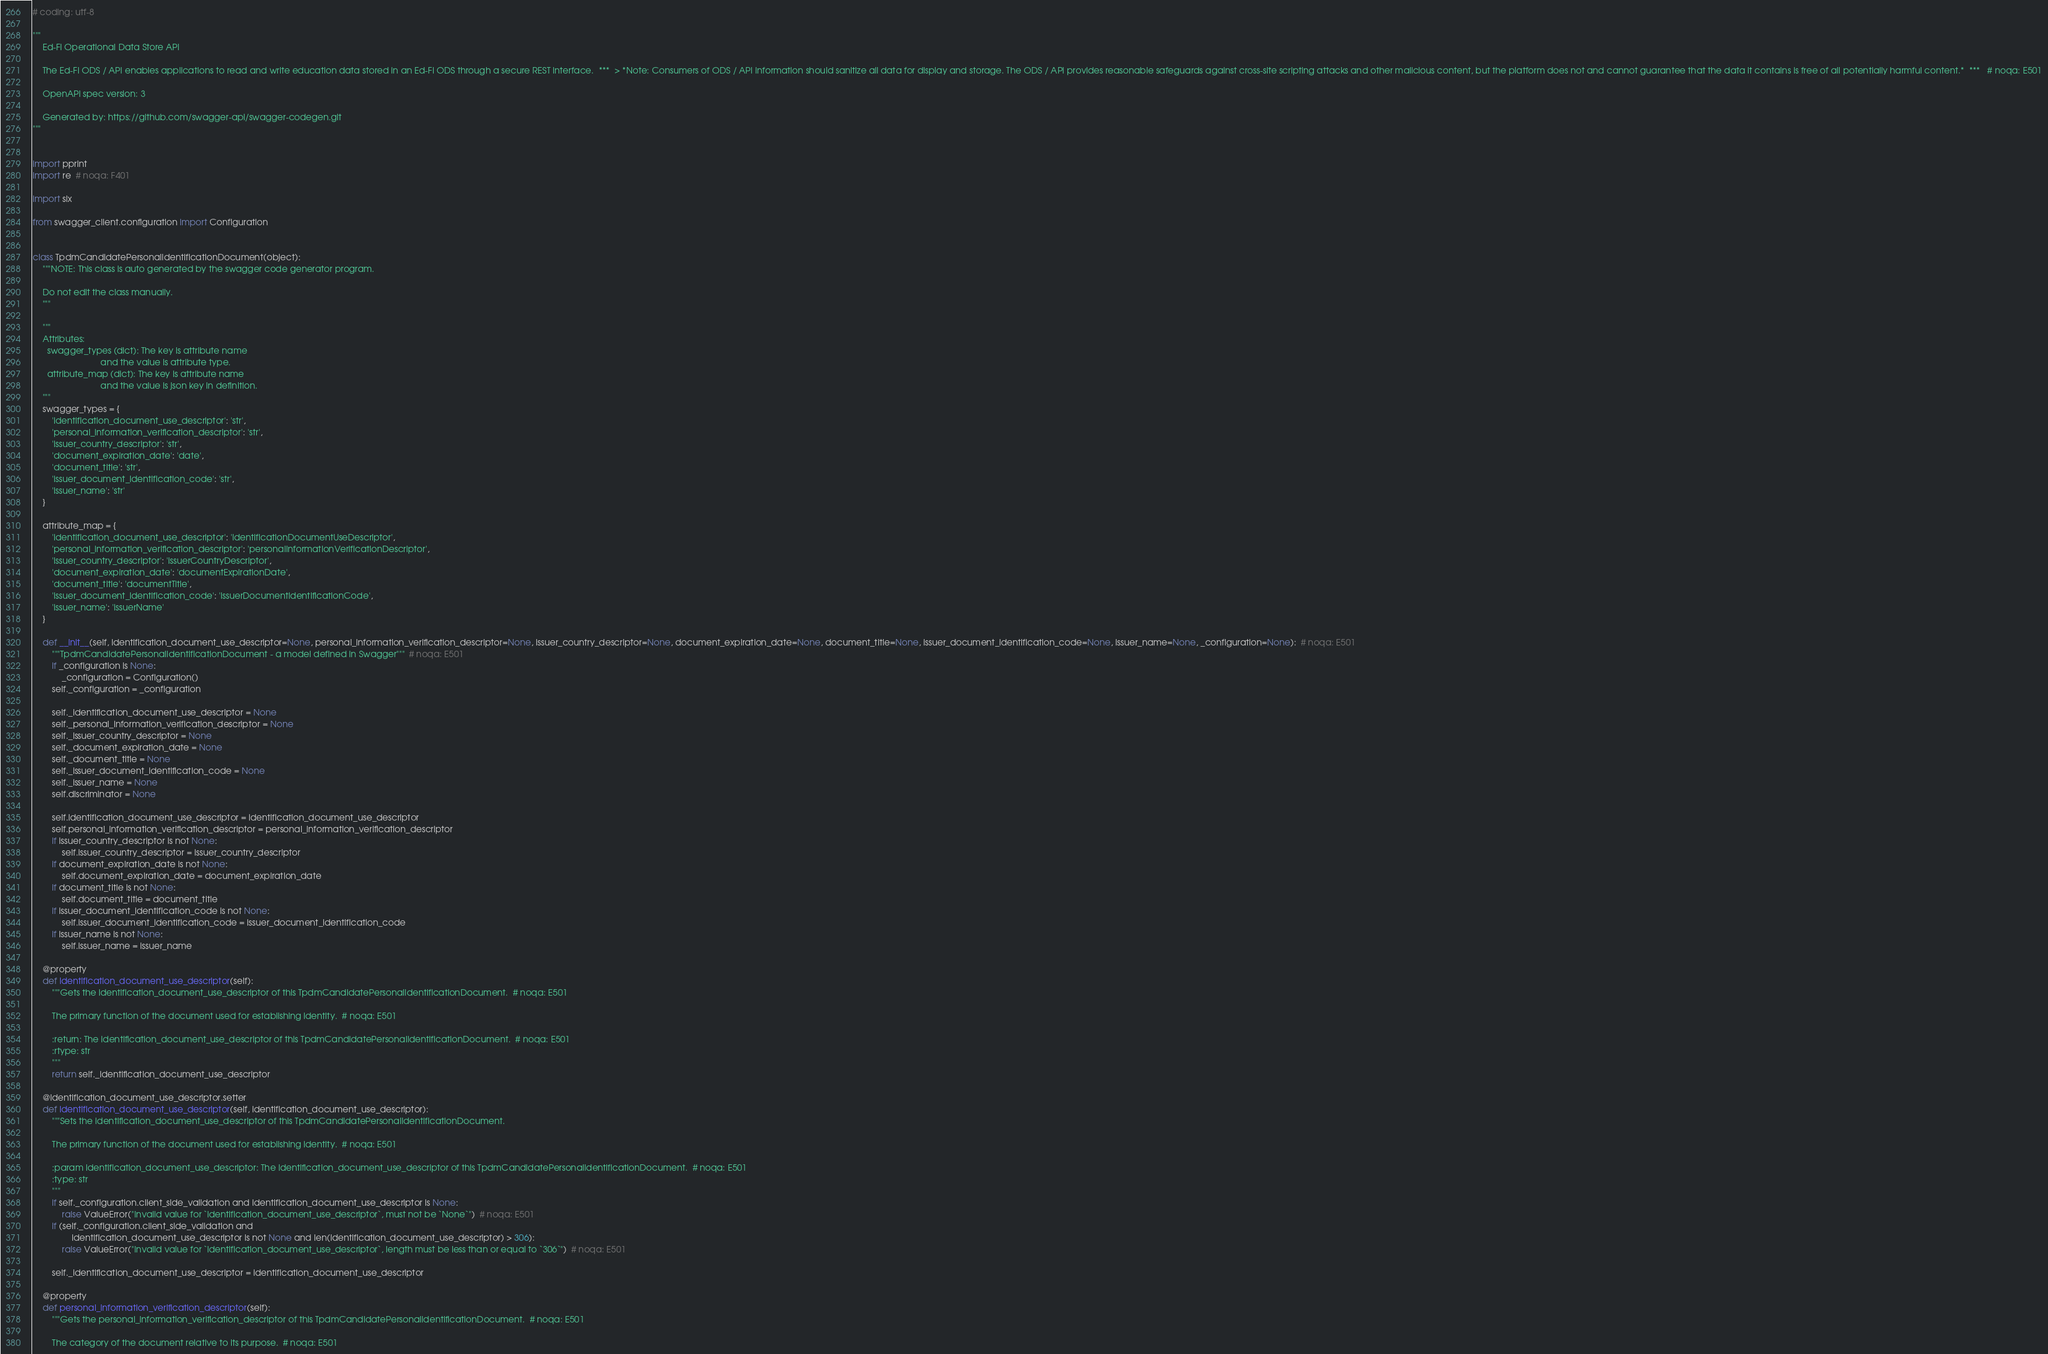Convert code to text. <code><loc_0><loc_0><loc_500><loc_500><_Python_># coding: utf-8

"""
    Ed-Fi Operational Data Store API

    The Ed-Fi ODS / API enables applications to read and write education data stored in an Ed-Fi ODS through a secure REST interface.  ***  > *Note: Consumers of ODS / API information should sanitize all data for display and storage. The ODS / API provides reasonable safeguards against cross-site scripting attacks and other malicious content, but the platform does not and cannot guarantee that the data it contains is free of all potentially harmful content.*  ***   # noqa: E501

    OpenAPI spec version: 3
    
    Generated by: https://github.com/swagger-api/swagger-codegen.git
"""


import pprint
import re  # noqa: F401

import six

from swagger_client.configuration import Configuration


class TpdmCandidatePersonalIdentificationDocument(object):
    """NOTE: This class is auto generated by the swagger code generator program.

    Do not edit the class manually.
    """

    """
    Attributes:
      swagger_types (dict): The key is attribute name
                            and the value is attribute type.
      attribute_map (dict): The key is attribute name
                            and the value is json key in definition.
    """
    swagger_types = {
        'identification_document_use_descriptor': 'str',
        'personal_information_verification_descriptor': 'str',
        'issuer_country_descriptor': 'str',
        'document_expiration_date': 'date',
        'document_title': 'str',
        'issuer_document_identification_code': 'str',
        'issuer_name': 'str'
    }

    attribute_map = {
        'identification_document_use_descriptor': 'identificationDocumentUseDescriptor',
        'personal_information_verification_descriptor': 'personalInformationVerificationDescriptor',
        'issuer_country_descriptor': 'issuerCountryDescriptor',
        'document_expiration_date': 'documentExpirationDate',
        'document_title': 'documentTitle',
        'issuer_document_identification_code': 'issuerDocumentIdentificationCode',
        'issuer_name': 'issuerName'
    }

    def __init__(self, identification_document_use_descriptor=None, personal_information_verification_descriptor=None, issuer_country_descriptor=None, document_expiration_date=None, document_title=None, issuer_document_identification_code=None, issuer_name=None, _configuration=None):  # noqa: E501
        """TpdmCandidatePersonalIdentificationDocument - a model defined in Swagger"""  # noqa: E501
        if _configuration is None:
            _configuration = Configuration()
        self._configuration = _configuration

        self._identification_document_use_descriptor = None
        self._personal_information_verification_descriptor = None
        self._issuer_country_descriptor = None
        self._document_expiration_date = None
        self._document_title = None
        self._issuer_document_identification_code = None
        self._issuer_name = None
        self.discriminator = None

        self.identification_document_use_descriptor = identification_document_use_descriptor
        self.personal_information_verification_descriptor = personal_information_verification_descriptor
        if issuer_country_descriptor is not None:
            self.issuer_country_descriptor = issuer_country_descriptor
        if document_expiration_date is not None:
            self.document_expiration_date = document_expiration_date
        if document_title is not None:
            self.document_title = document_title
        if issuer_document_identification_code is not None:
            self.issuer_document_identification_code = issuer_document_identification_code
        if issuer_name is not None:
            self.issuer_name = issuer_name

    @property
    def identification_document_use_descriptor(self):
        """Gets the identification_document_use_descriptor of this TpdmCandidatePersonalIdentificationDocument.  # noqa: E501

        The primary function of the document used for establishing identity.  # noqa: E501

        :return: The identification_document_use_descriptor of this TpdmCandidatePersonalIdentificationDocument.  # noqa: E501
        :rtype: str
        """
        return self._identification_document_use_descriptor

    @identification_document_use_descriptor.setter
    def identification_document_use_descriptor(self, identification_document_use_descriptor):
        """Sets the identification_document_use_descriptor of this TpdmCandidatePersonalIdentificationDocument.

        The primary function of the document used for establishing identity.  # noqa: E501

        :param identification_document_use_descriptor: The identification_document_use_descriptor of this TpdmCandidatePersonalIdentificationDocument.  # noqa: E501
        :type: str
        """
        if self._configuration.client_side_validation and identification_document_use_descriptor is None:
            raise ValueError("Invalid value for `identification_document_use_descriptor`, must not be `None`")  # noqa: E501
        if (self._configuration.client_side_validation and
                identification_document_use_descriptor is not None and len(identification_document_use_descriptor) > 306):
            raise ValueError("Invalid value for `identification_document_use_descriptor`, length must be less than or equal to `306`")  # noqa: E501

        self._identification_document_use_descriptor = identification_document_use_descriptor

    @property
    def personal_information_verification_descriptor(self):
        """Gets the personal_information_verification_descriptor of this TpdmCandidatePersonalIdentificationDocument.  # noqa: E501

        The category of the document relative to its purpose.  # noqa: E501
</code> 